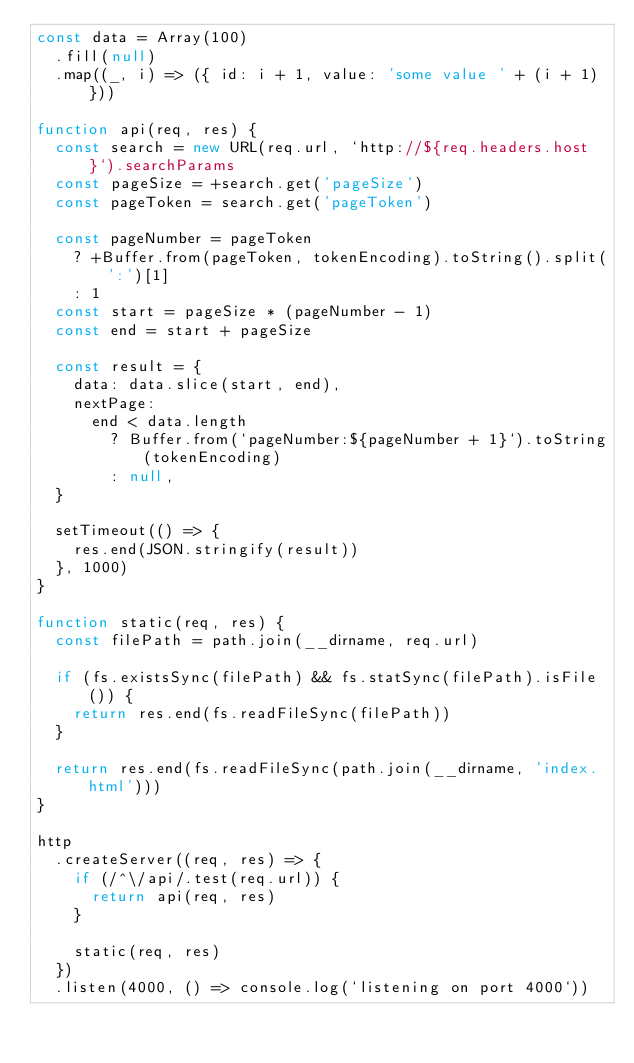Convert code to text. <code><loc_0><loc_0><loc_500><loc_500><_JavaScript_>const data = Array(100)
  .fill(null)
  .map((_, i) => ({ id: i + 1, value: 'some value ' + (i + 1) }))

function api(req, res) {
  const search = new URL(req.url, `http://${req.headers.host}`).searchParams
  const pageSize = +search.get('pageSize')
  const pageToken = search.get('pageToken')

  const pageNumber = pageToken
    ? +Buffer.from(pageToken, tokenEncoding).toString().split(':')[1]
    : 1
  const start = pageSize * (pageNumber - 1)
  const end = start + pageSize

  const result = {
    data: data.slice(start, end),
    nextPage:
      end < data.length
        ? Buffer.from(`pageNumber:${pageNumber + 1}`).toString(tokenEncoding)
        : null,
  }

  setTimeout(() => {
    res.end(JSON.stringify(result))
  }, 1000)
}

function static(req, res) {
  const filePath = path.join(__dirname, req.url)

  if (fs.existsSync(filePath) && fs.statSync(filePath).isFile()) {
    return res.end(fs.readFileSync(filePath))
  }

  return res.end(fs.readFileSync(path.join(__dirname, 'index.html')))
}

http
  .createServer((req, res) => {
    if (/^\/api/.test(req.url)) {
      return api(req, res)
    }

    static(req, res)
  })
  .listen(4000, () => console.log(`listening on port 4000`))
</code> 